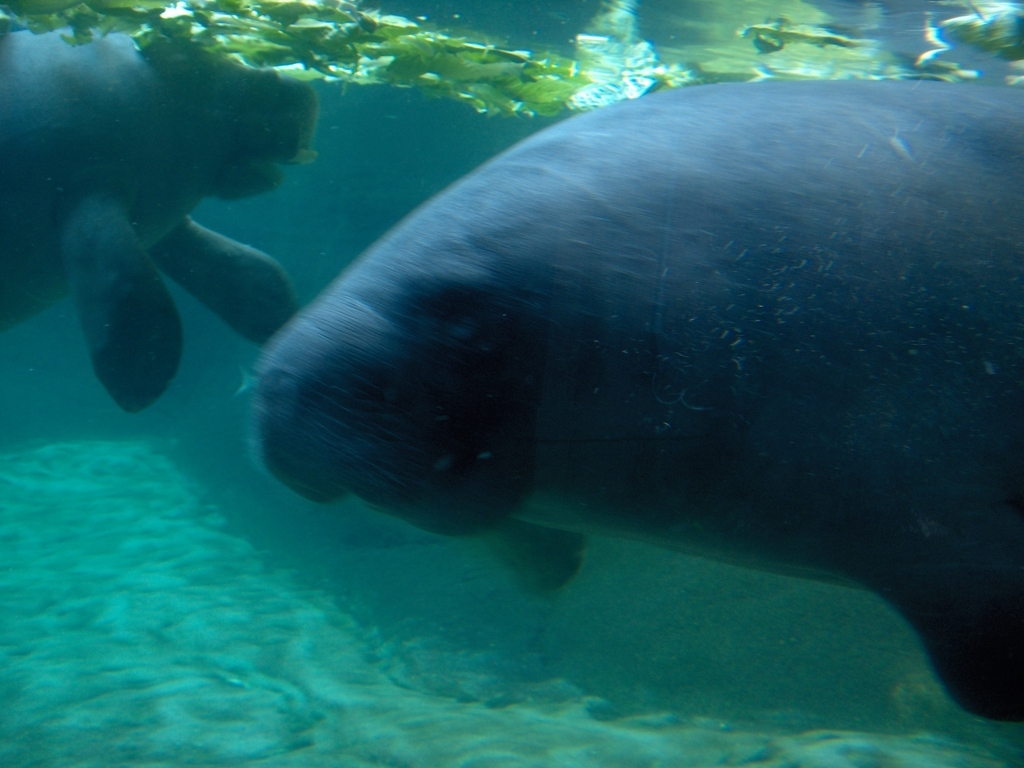Can you tell me about their habitat? Manatees are typically found in warm, shallow coastal areas and rivers where they subsist on a diet of sea grass and other aquatic plants. This image seems to depict them in a naturalistic underwater environment, possibly a river or a protected marine area. 